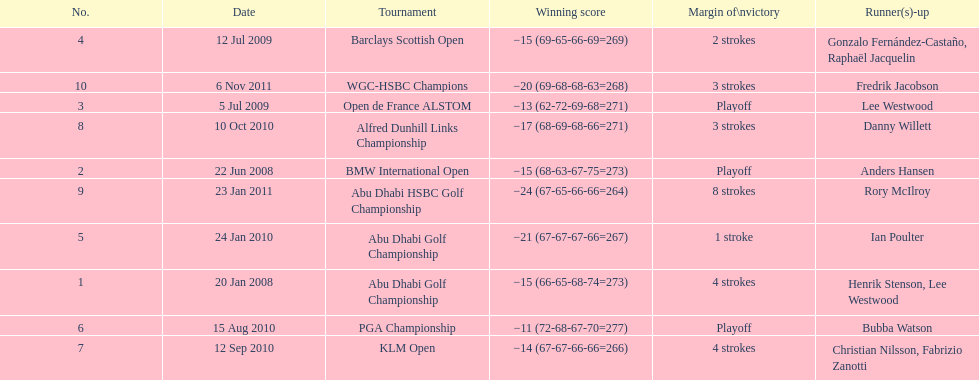How many total tournaments has he won? 10. 